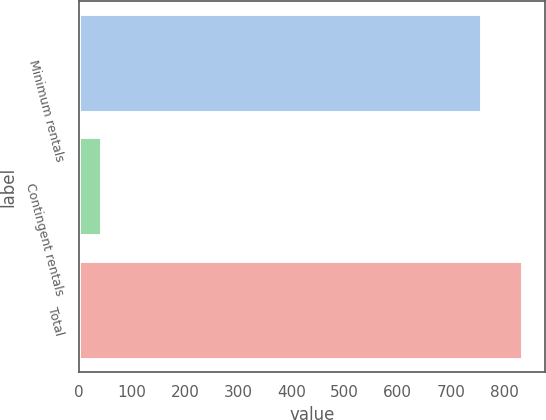<chart> <loc_0><loc_0><loc_500><loc_500><bar_chart><fcel>Minimum rentals<fcel>Contingent rentals<fcel>Total<nl><fcel>759<fcel>44.7<fcel>834.9<nl></chart> 